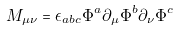Convert formula to latex. <formula><loc_0><loc_0><loc_500><loc_500>M _ { \mu \nu } = \epsilon _ { a b c } \Phi ^ { a } \partial _ { \mu } \Phi ^ { b } \partial _ { \nu } \Phi ^ { c }</formula> 